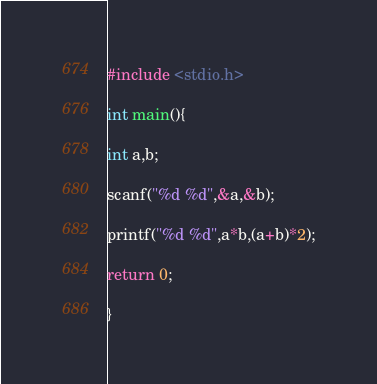Convert code to text. <code><loc_0><loc_0><loc_500><loc_500><_C_>#include <stdio.h>

int main(){

int a,b;

scanf("%d %d",&a,&b);

printf("%d %d",a*b,(a+b)*2);

return 0;

}</code> 